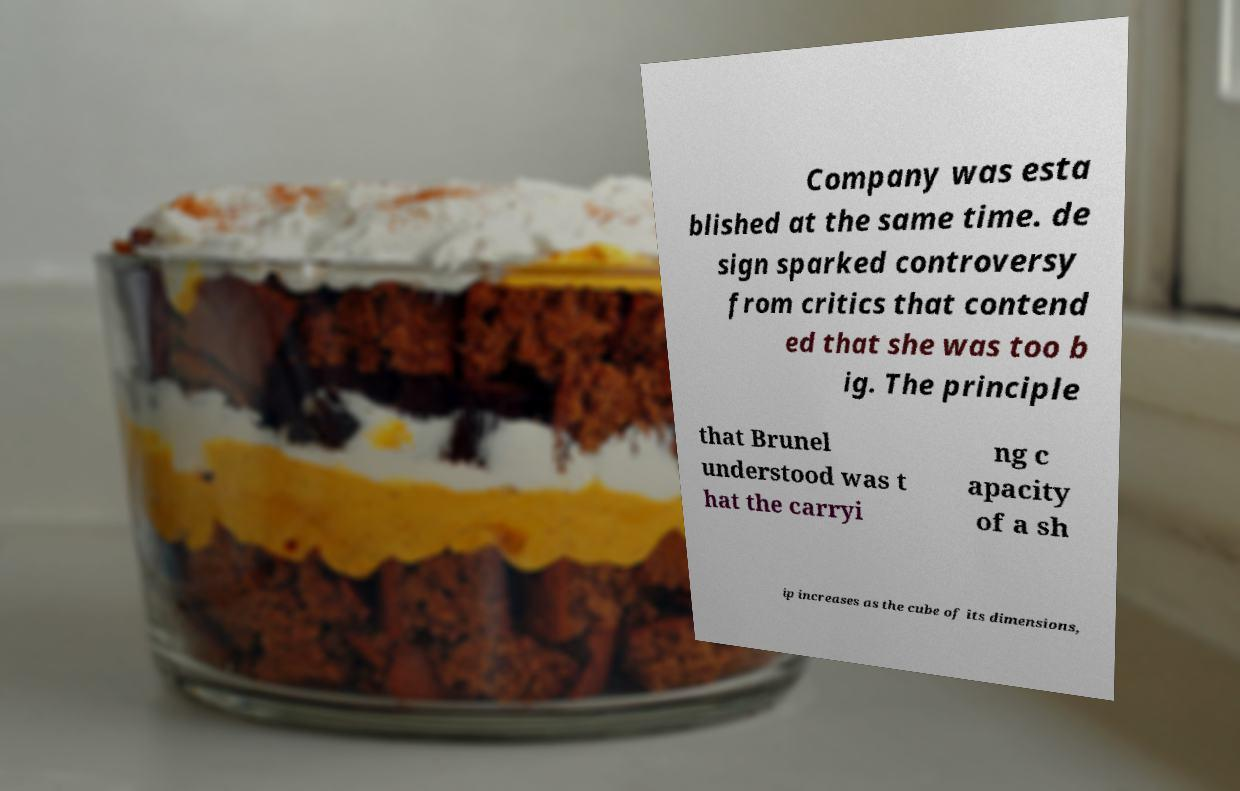Please read and relay the text visible in this image. What does it say? Company was esta blished at the same time. de sign sparked controversy from critics that contend ed that she was too b ig. The principle that Brunel understood was t hat the carryi ng c apacity of a sh ip increases as the cube of its dimensions, 